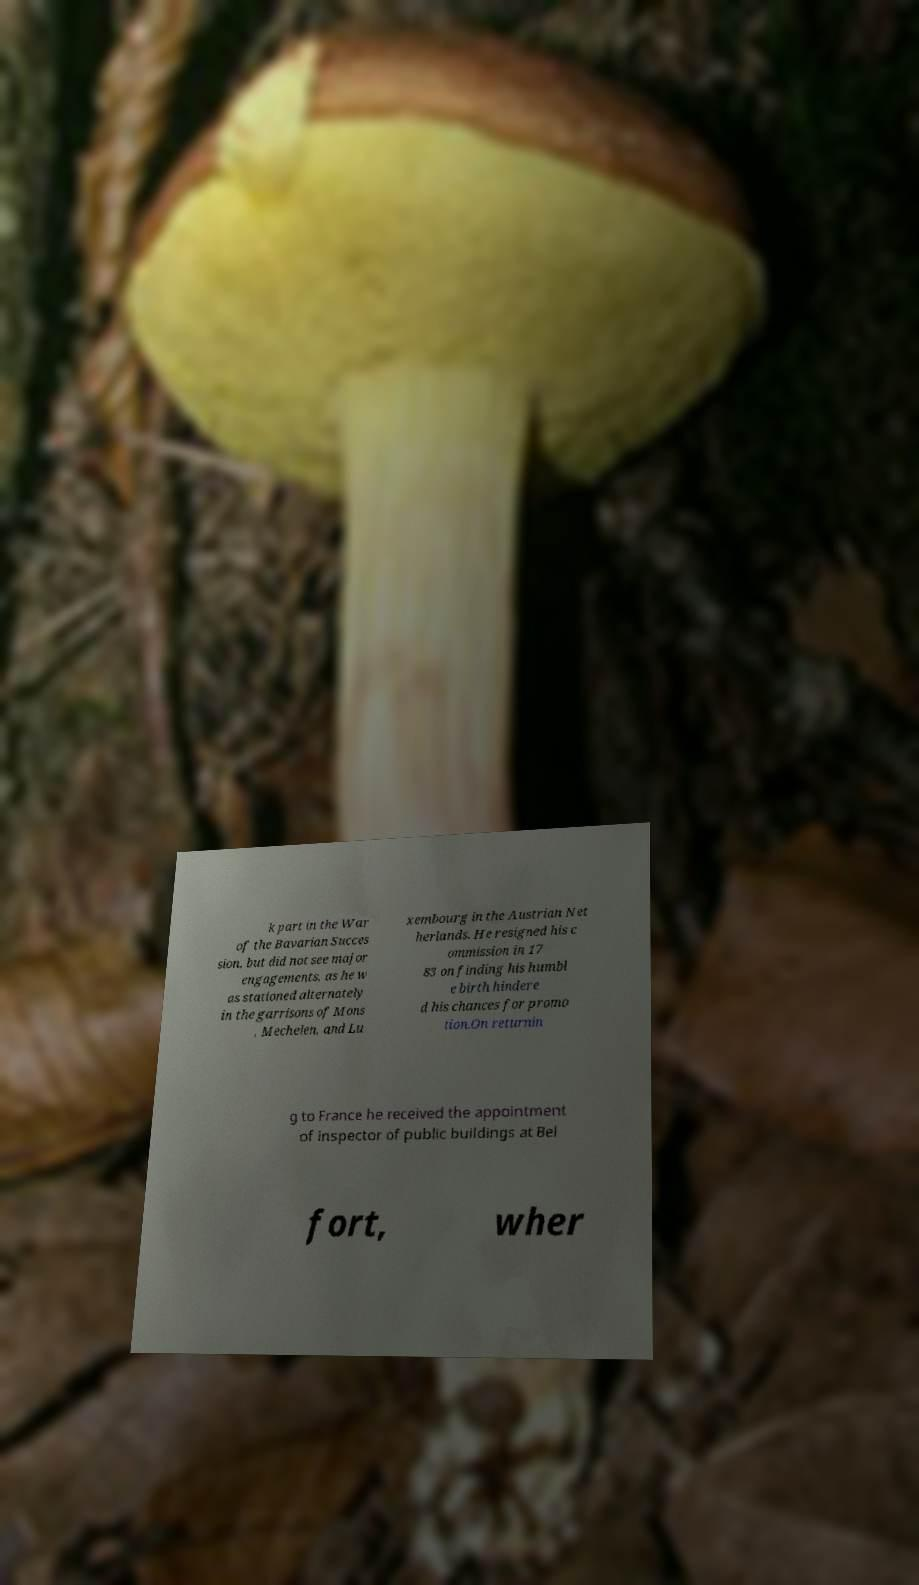Can you read and provide the text displayed in the image?This photo seems to have some interesting text. Can you extract and type it out for me? k part in the War of the Bavarian Succes sion, but did not see major engagements, as he w as stationed alternately in the garrisons of Mons , Mechelen, and Lu xembourg in the Austrian Net herlands. He resigned his c ommission in 17 83 on finding his humbl e birth hindere d his chances for promo tion.On returnin g to France he received the appointment of inspector of public buildings at Bel fort, wher 